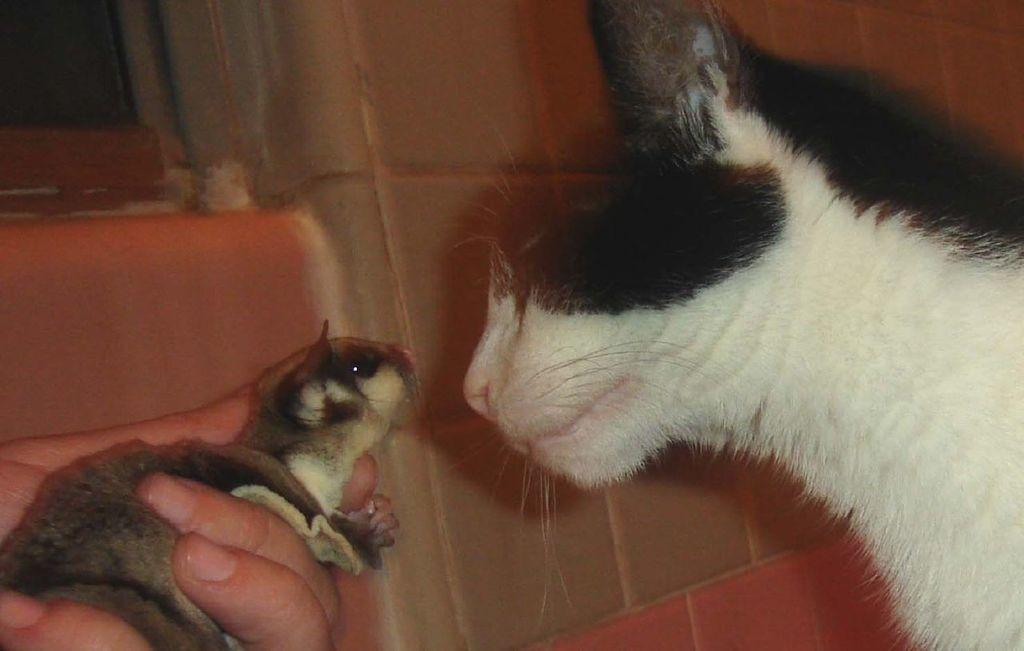What type of animal is in the image? There is a cat in the image. How is the cat being held in the image? The cat is in a person's hand. What can be seen in the background of the image? There is a wall and a window in the background of the image. What type of fruit is the cat eating in the image? There is no fruit present in the image, and the cat is not shown eating anything. Can you see a snake in the image? No, there is no snake present in the image. 